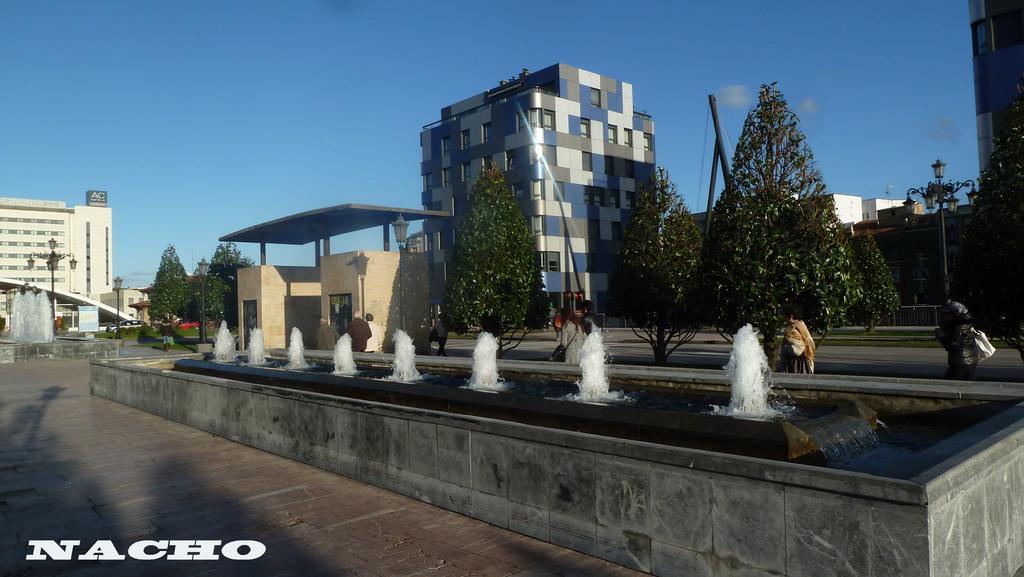Can you describe this image briefly? In this image I can see waterfalls, background I can see group of people walking, trees in green color, buildings in cream, blue and white color, and sky is in blue color. 